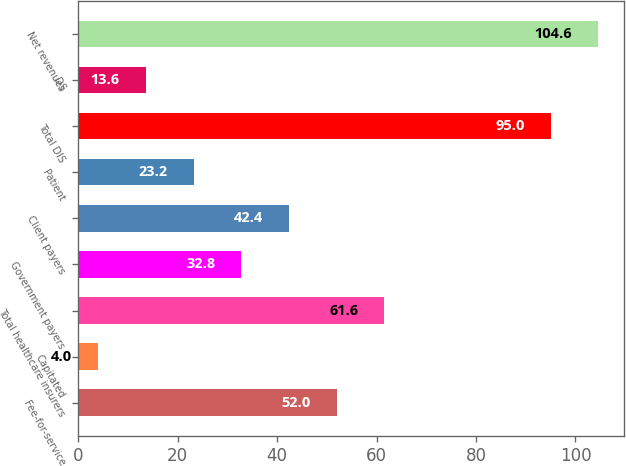<chart> <loc_0><loc_0><loc_500><loc_500><bar_chart><fcel>Fee-for-service<fcel>Capitated<fcel>Total healthcare insurers<fcel>Government payers<fcel>Client payers<fcel>Patient<fcel>Total DIS<fcel>DS<fcel>Net revenues<nl><fcel>52<fcel>4<fcel>61.6<fcel>32.8<fcel>42.4<fcel>23.2<fcel>95<fcel>13.6<fcel>104.6<nl></chart> 